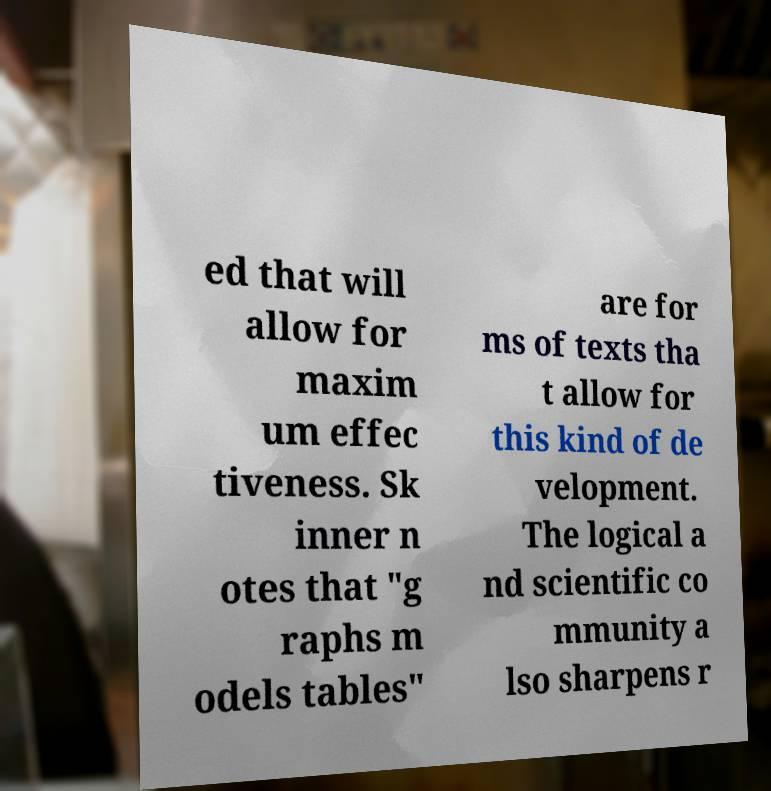Please identify and transcribe the text found in this image. ed that will allow for maxim um effec tiveness. Sk inner n otes that "g raphs m odels tables" are for ms of texts tha t allow for this kind of de velopment. The logical a nd scientific co mmunity a lso sharpens r 